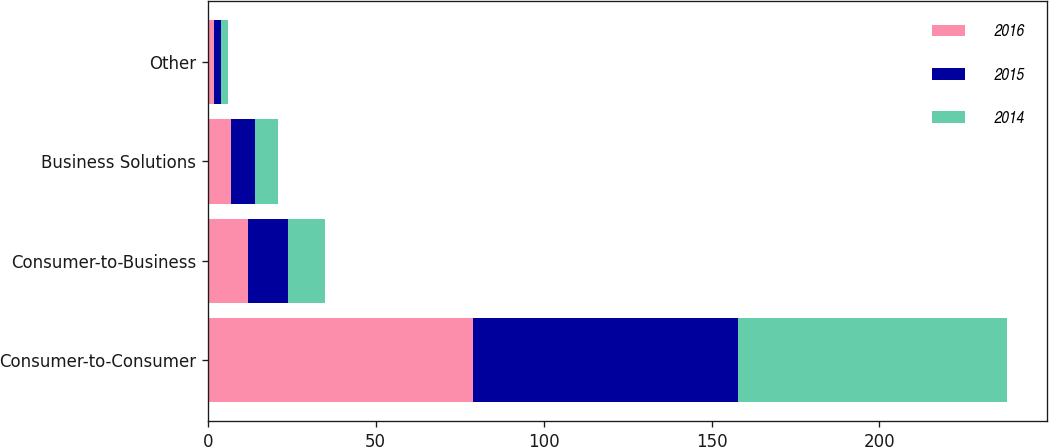Convert chart. <chart><loc_0><loc_0><loc_500><loc_500><stacked_bar_chart><ecel><fcel>Consumer-to-Consumer<fcel>Consumer-to-Business<fcel>Business Solutions<fcel>Other<nl><fcel>2016<fcel>79<fcel>12<fcel>7<fcel>2<nl><fcel>2015<fcel>79<fcel>12<fcel>7<fcel>2<nl><fcel>2014<fcel>80<fcel>11<fcel>7<fcel>2<nl></chart> 